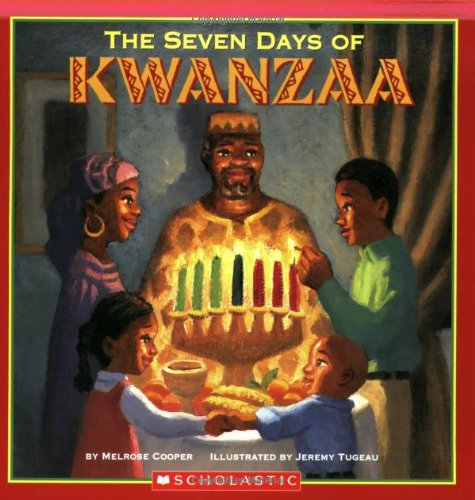Who wrote this book? The author of the book is Melrose Cooper. This book represents an important cultural exploration suitable for children, making it an intriguing educational resource. 